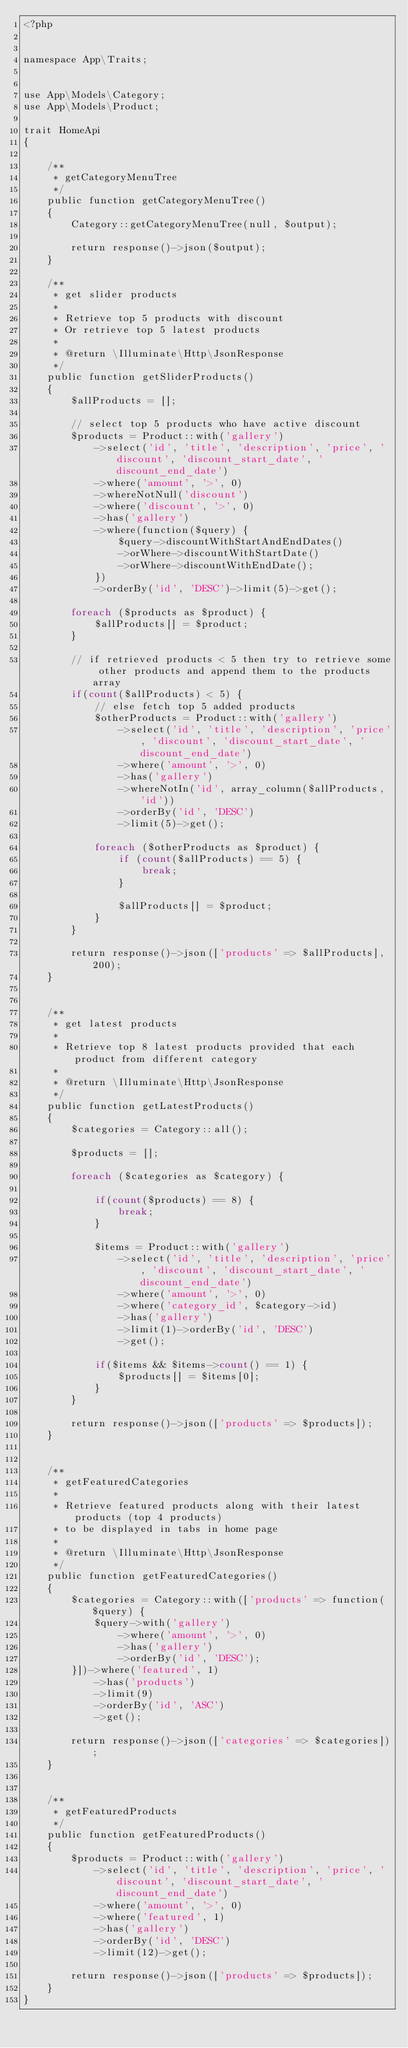<code> <loc_0><loc_0><loc_500><loc_500><_PHP_><?php


namespace App\Traits;


use App\Models\Category;
use App\Models\Product;

trait HomeApi
{

    /**
     * getCategoryMenuTree
     */
    public function getCategoryMenuTree()
    {
        Category::getCategoryMenuTree(null, $output);

        return response()->json($output);
    }

    /**
     * get slider products
     *
     * Retrieve top 5 products with discount
     * Or retrieve top 5 latest products
     *
     * @return \Illuminate\Http\JsonResponse
     */
    public function getSliderProducts()
    {
        $allProducts = [];

        // select top 5 products who have active discount
        $products = Product::with('gallery')
            ->select('id', 'title', 'description', 'price', 'discount', 'discount_start_date', 'discount_end_date')
            ->where('amount', '>', 0)
            ->whereNotNull('discount')
            ->where('discount', '>', 0)
            ->has('gallery')
            ->where(function($query) {
                $query->discountWithStartAndEndDates()
                ->orWhere->discountWithStartDate()
                ->orWhere->discountWithEndDate();
            })
            ->orderBy('id', 'DESC')->limit(5)->get();

        foreach ($products as $product) {
            $allProducts[] = $product;
        }

        // if retrieved products < 5 then try to retrieve some other products and append them to the products array
        if(count($allProducts) < 5) {
            // else fetch top 5 added products
            $otherProducts = Product::with('gallery')
                ->select('id', 'title', 'description', 'price', 'discount', 'discount_start_date', 'discount_end_date')
                ->where('amount', '>', 0)
                ->has('gallery')
                ->whereNotIn('id', array_column($allProducts, 'id'))
                ->orderBy('id', 'DESC')
                ->limit(5)->get();

            foreach ($otherProducts as $product) {
                if (count($allProducts) == 5) {
                    break;
                }

                $allProducts[] = $product;
            }
        }

        return response()->json(['products' => $allProducts], 200);
    }


    /**
     * get latest products
     *
     * Retrieve top 8 latest products provided that each product from different category
     *
     * @return \Illuminate\Http\JsonResponse
     */
    public function getLatestProducts()
    {
        $categories = Category::all();

        $products = [];

        foreach ($categories as $category) {

            if(count($products) == 8) {
                break;
            }

            $items = Product::with('gallery')
                ->select('id', 'title', 'description', 'price', 'discount', 'discount_start_date', 'discount_end_date')
                ->where('amount', '>', 0)
                ->where('category_id', $category->id)
                ->has('gallery')
                ->limit(1)->orderBy('id', 'DESC')
                ->get();

            if($items && $items->count() == 1) {
                $products[] = $items[0];
            }
        }

        return response()->json(['products' => $products]);
    }


    /**
     * getFeaturedCategories
     *
     * Retrieve featured products along with their latest products (top 4 products)
     * to be displayed in tabs in home page
     *
     * @return \Illuminate\Http\JsonResponse
     */
    public function getFeaturedCategories()
    {
        $categories = Category::with(['products' => function($query) {
            $query->with('gallery')
                ->where('amount', '>', 0)
                ->has('gallery')
                ->orderBy('id', 'DESC');
        }])->where('featured', 1)
            ->has('products')
            ->limit(9)
            ->orderBy('id', 'ASC')
            ->get();

        return response()->json(['categories' => $categories]);
    }


    /**
     * getFeaturedProducts
     */
    public function getFeaturedProducts()
    {
        $products = Product::with('gallery')
            ->select('id', 'title', 'description', 'price', 'discount', 'discount_start_date', 'discount_end_date')
            ->where('amount', '>', 0)
            ->where('featured', 1)
            ->has('gallery')
            ->orderBy('id', 'DESC')
            ->limit(12)->get();

        return response()->json(['products' => $products]);
    }
}
</code> 